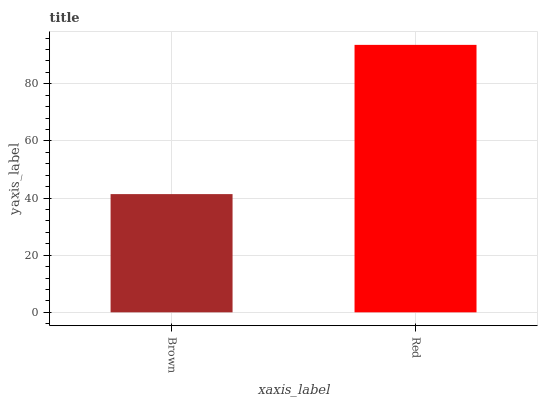Is Red the maximum?
Answer yes or no. Yes. Is Red the minimum?
Answer yes or no. No. Is Red greater than Brown?
Answer yes or no. Yes. Is Brown less than Red?
Answer yes or no. Yes. Is Brown greater than Red?
Answer yes or no. No. Is Red less than Brown?
Answer yes or no. No. Is Red the high median?
Answer yes or no. Yes. Is Brown the low median?
Answer yes or no. Yes. Is Brown the high median?
Answer yes or no. No. Is Red the low median?
Answer yes or no. No. 